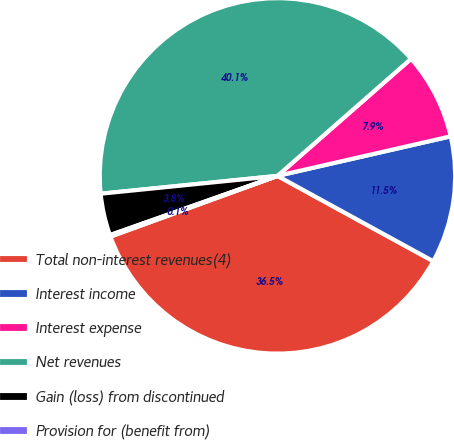Convert chart. <chart><loc_0><loc_0><loc_500><loc_500><pie_chart><fcel>Total non-interest revenues(4)<fcel>Interest income<fcel>Interest expense<fcel>Net revenues<fcel>Gain (loss) from discontinued<fcel>Provision for (benefit from)<nl><fcel>36.48%<fcel>11.55%<fcel>7.88%<fcel>40.15%<fcel>3.81%<fcel>0.14%<nl></chart> 